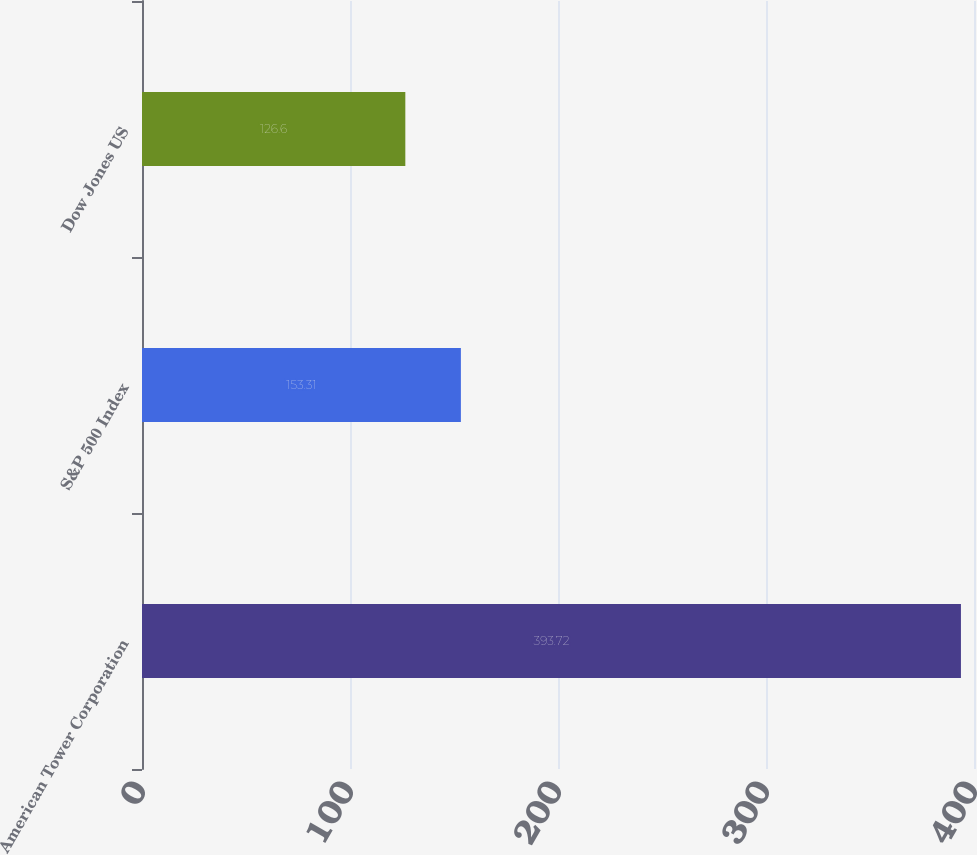Convert chart to OTSL. <chart><loc_0><loc_0><loc_500><loc_500><bar_chart><fcel>American Tower Corporation<fcel>S&P 500 Index<fcel>Dow Jones US<nl><fcel>393.72<fcel>153.31<fcel>126.6<nl></chart> 